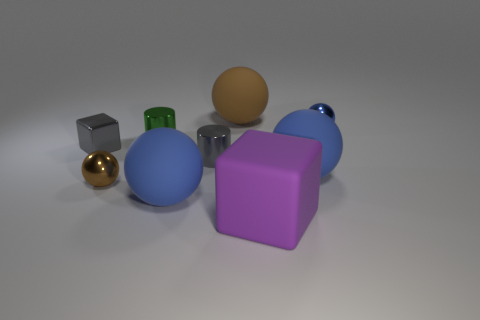Subtract all brown blocks. How many blue balls are left? 3 Subtract all big brown spheres. How many spheres are left? 4 Subtract all green spheres. Subtract all yellow blocks. How many spheres are left? 5 Add 1 green objects. How many objects exist? 10 Subtract all cylinders. How many objects are left? 7 Add 6 large blue cylinders. How many large blue cylinders exist? 6 Subtract 0 yellow cylinders. How many objects are left? 9 Subtract all small gray shiny cubes. Subtract all tiny green metallic objects. How many objects are left? 7 Add 6 small green cylinders. How many small green cylinders are left? 7 